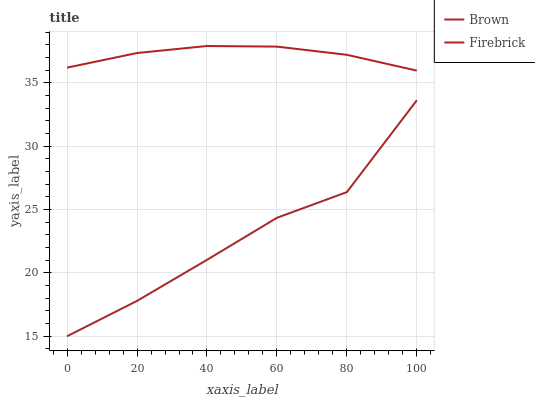Does Brown have the minimum area under the curve?
Answer yes or no. Yes. Does Firebrick have the maximum area under the curve?
Answer yes or no. Yes. Does Firebrick have the minimum area under the curve?
Answer yes or no. No. Is Firebrick the smoothest?
Answer yes or no. Yes. Is Brown the roughest?
Answer yes or no. Yes. Is Firebrick the roughest?
Answer yes or no. No. Does Brown have the lowest value?
Answer yes or no. Yes. Does Firebrick have the lowest value?
Answer yes or no. No. Does Firebrick have the highest value?
Answer yes or no. Yes. Is Brown less than Firebrick?
Answer yes or no. Yes. Is Firebrick greater than Brown?
Answer yes or no. Yes. Does Brown intersect Firebrick?
Answer yes or no. No. 